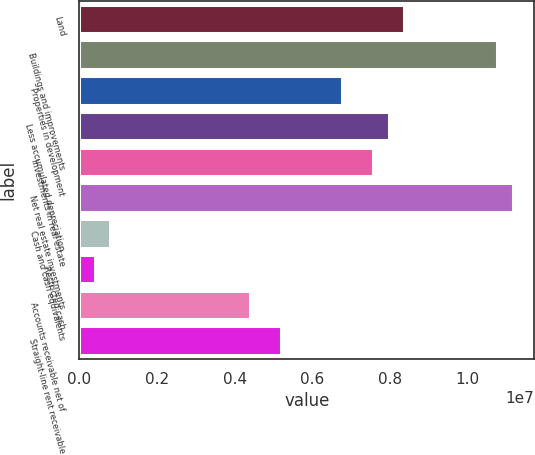Convert chart. <chart><loc_0><loc_0><loc_500><loc_500><bar_chart><fcel>Land<fcel>Buildings and improvements<fcel>Properties in development<fcel>Less accumulated depreciation<fcel>Investments in real estate<fcel>Net real estate investments<fcel>Cash and cash equivalents<fcel>Restricted cash<fcel>Accounts receivable net of<fcel>Straight-line rent receivable<nl><fcel>8.37179e+06<fcel>1.07635e+07<fcel>6.77735e+06<fcel>7.97318e+06<fcel>7.57457e+06<fcel>1.11621e+07<fcel>798185<fcel>399574<fcel>4.38568e+06<fcel>5.1829e+06<nl></chart> 